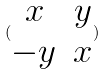<formula> <loc_0><loc_0><loc_500><loc_500>( \begin{matrix} x & y \\ - y & x \end{matrix} )</formula> 